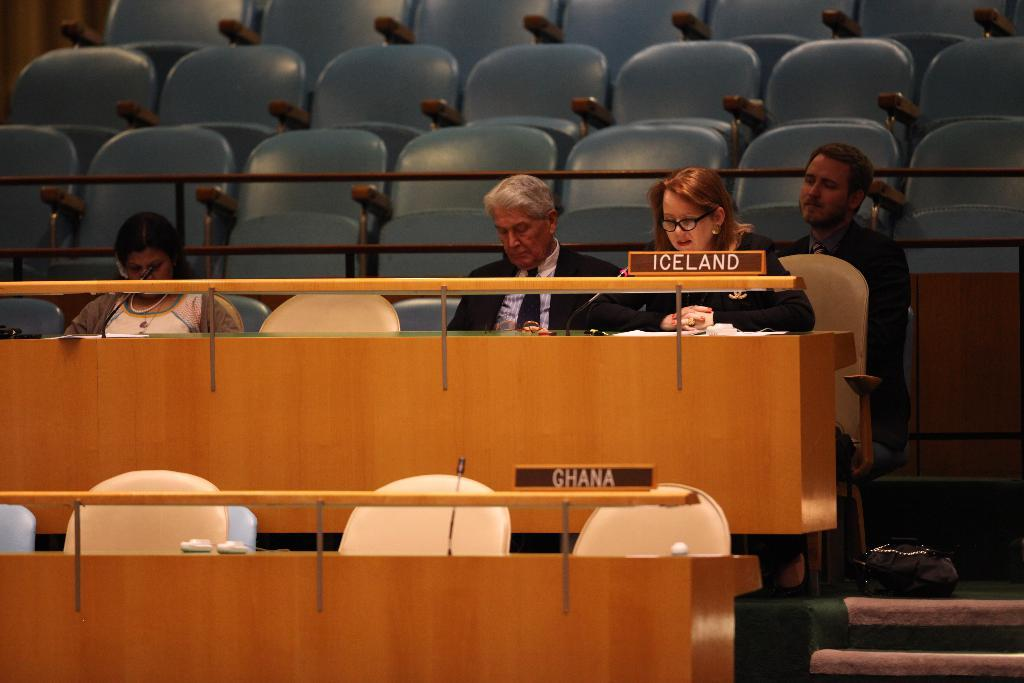<image>
Relay a brief, clear account of the picture shown. In a government meeting, the Ghana section is empty but the Iceland section contains several people. 